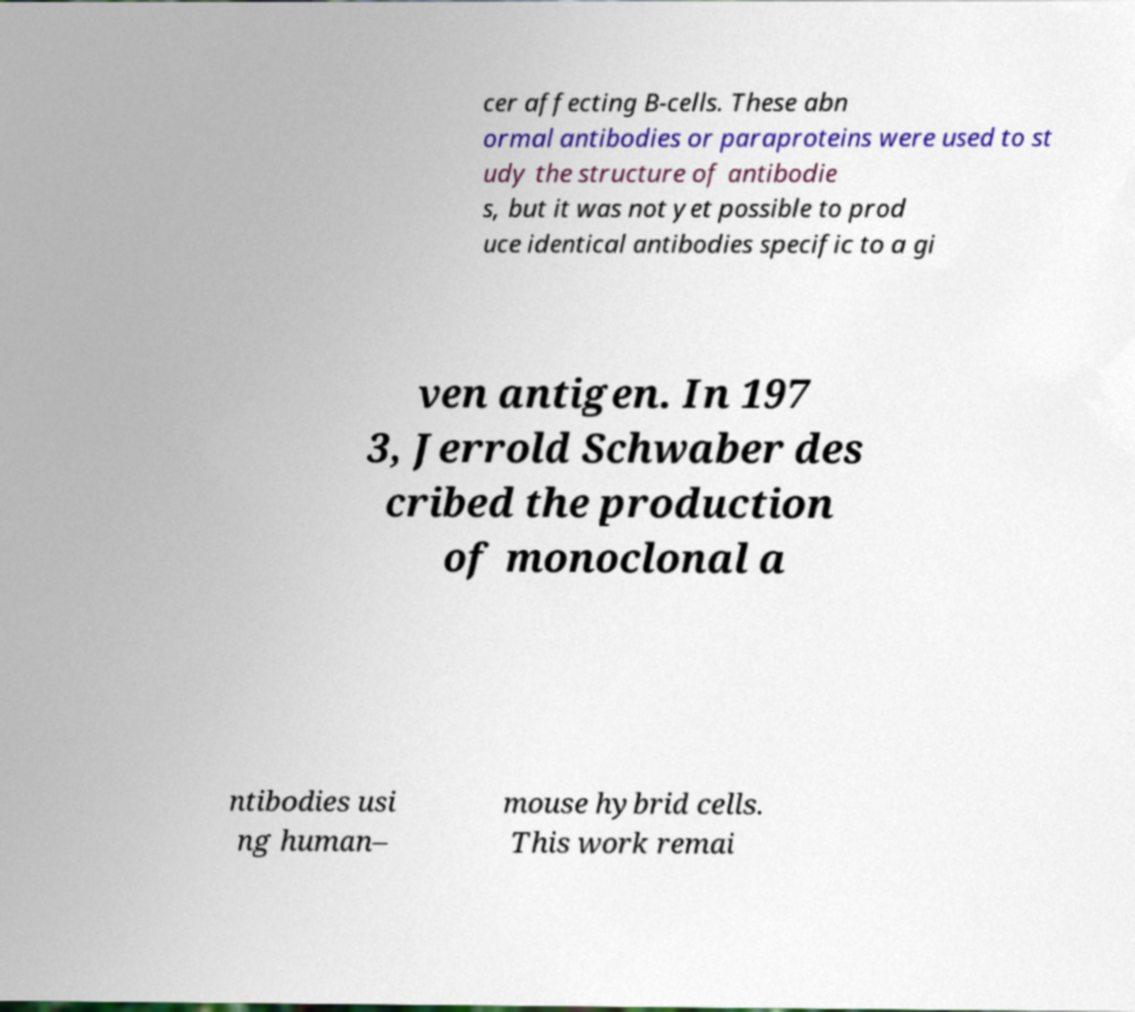Could you assist in decoding the text presented in this image and type it out clearly? cer affecting B-cells. These abn ormal antibodies or paraproteins were used to st udy the structure of antibodie s, but it was not yet possible to prod uce identical antibodies specific to a gi ven antigen. In 197 3, Jerrold Schwaber des cribed the production of monoclonal a ntibodies usi ng human– mouse hybrid cells. This work remai 